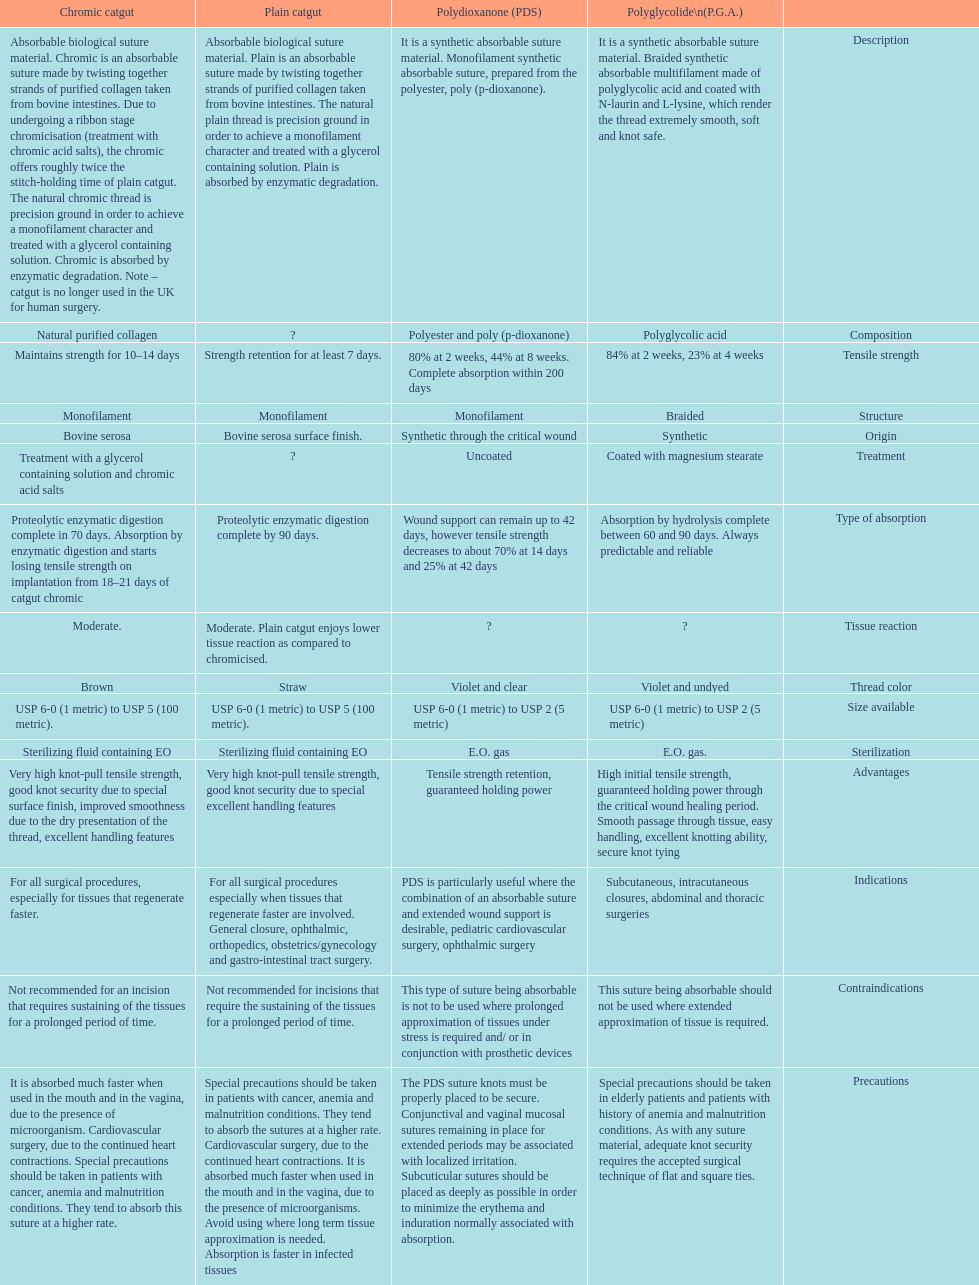How many days does the chronic catgut retain strength? Maintains strength for 10–14 days. What is plain catgut? Absorbable biological suture material. Plain is an absorbable suture made by twisting together strands of purified collagen taken from bovine intestines. The natural plain thread is precision ground in order to achieve a monofilament character and treated with a glycerol containing solution. Plain is absorbed by enzymatic degradation. How many days does catgut retain strength? Strength retention for at least 7 days. 